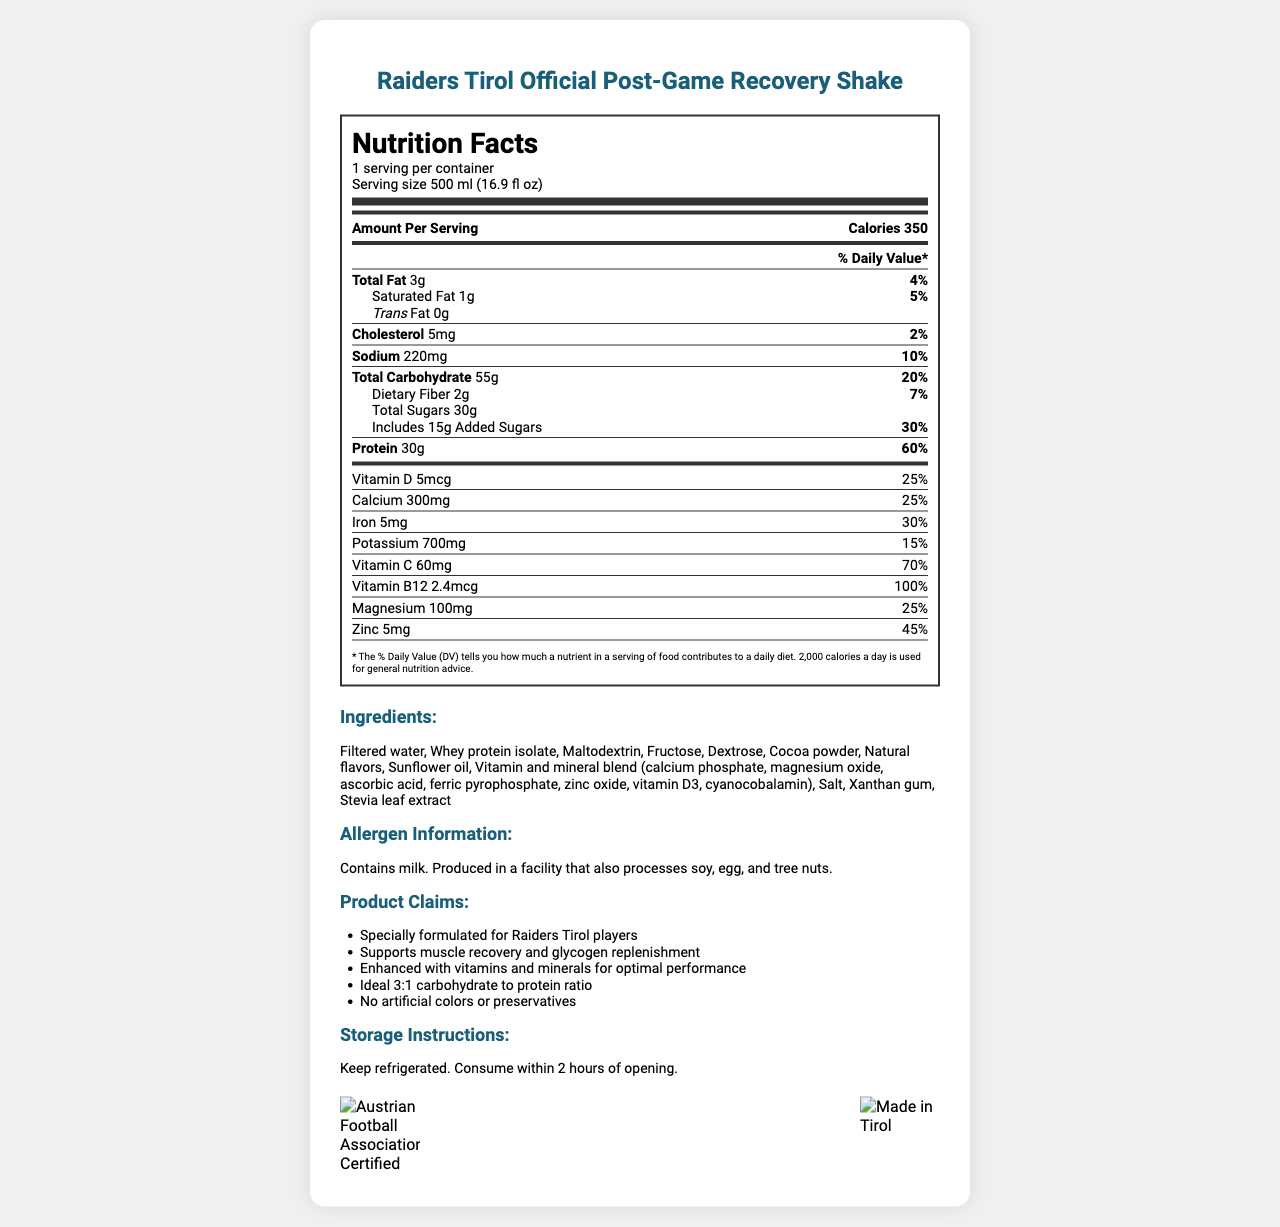what is the serving size of the Raiders Tirol Official Post-Game Recovery Shake? The document lists the serving size in the "serving info" section under the Nutrition Facts header as "500 ml (16.9 fl oz)".
Answer: 500 ml (16.9 fl oz) How many calories are in one serving of the shake? The document states "Calories 350" in the "Amount Per Serving" section of the Nutrition Facts.
Answer: 350 What is the total amount of protein in one serving? The document lists "Protein 30g" in the nutrient rows under the Nutrition Facts header.
Answer: 30g What percentage of the daily value for iron does one serving provide? The document lists "Iron 5mg" with a daily value percentage of "30%" in the nutrient rows.
Answer: 30% What is one of the product claims made for the Raiders Tirol Official Post-Game Recovery Shake? The document lists several product claims in the Product Claims section, including "Supports muscle recovery and glycogen replenishment".
Answer: Supports muscle recovery and glycogen replenishment How much vitamin D is in one serving of the shake? A. 3mcg B. 4mcg C. 5mcg D. 10mcg The document lists "Vitamin D 5mcg" in the vitamin and mineral information section.
Answer: C. 5mcg Which of the following ingredients is not listed in the Recovery Shake? 1. Maltodextrin 2. Ascorbic acid 3. Palm oil 4. Stevia leaf extract The document lists all the ingredients, and Palm oil is not one of them.
Answer: 3. Palm oil Is the shake certified by the Austrian Football Association? The document contains an Austrian Football Association Certification logo indicating it is certified by the association.
Answer: Yes Summarize the document. The document comprehensively covers the nutritional facts, key ingredients, and certifications of the product while emphasizing its benefits for post-game recovery.
Answer: This document provides the nutritional information, ingredients, allergen information, product claims, and certification details for the Raiders Tirol Official Post-Game Recovery Shake. The document details the nutrient amounts per serving and their respective daily values, lists the ingredient composition with a special vitamin and mineral blend, highlights product claims tailored to Raiders Tirol players, and includes storage instructions. Certifications from the Austrian Football Association and Tirol are also displayed. What time of the day is the recovery shake supposed to be consumed? The document does not specify a recommended time of day to consume the recovery shake.
Answer: Not enough information 